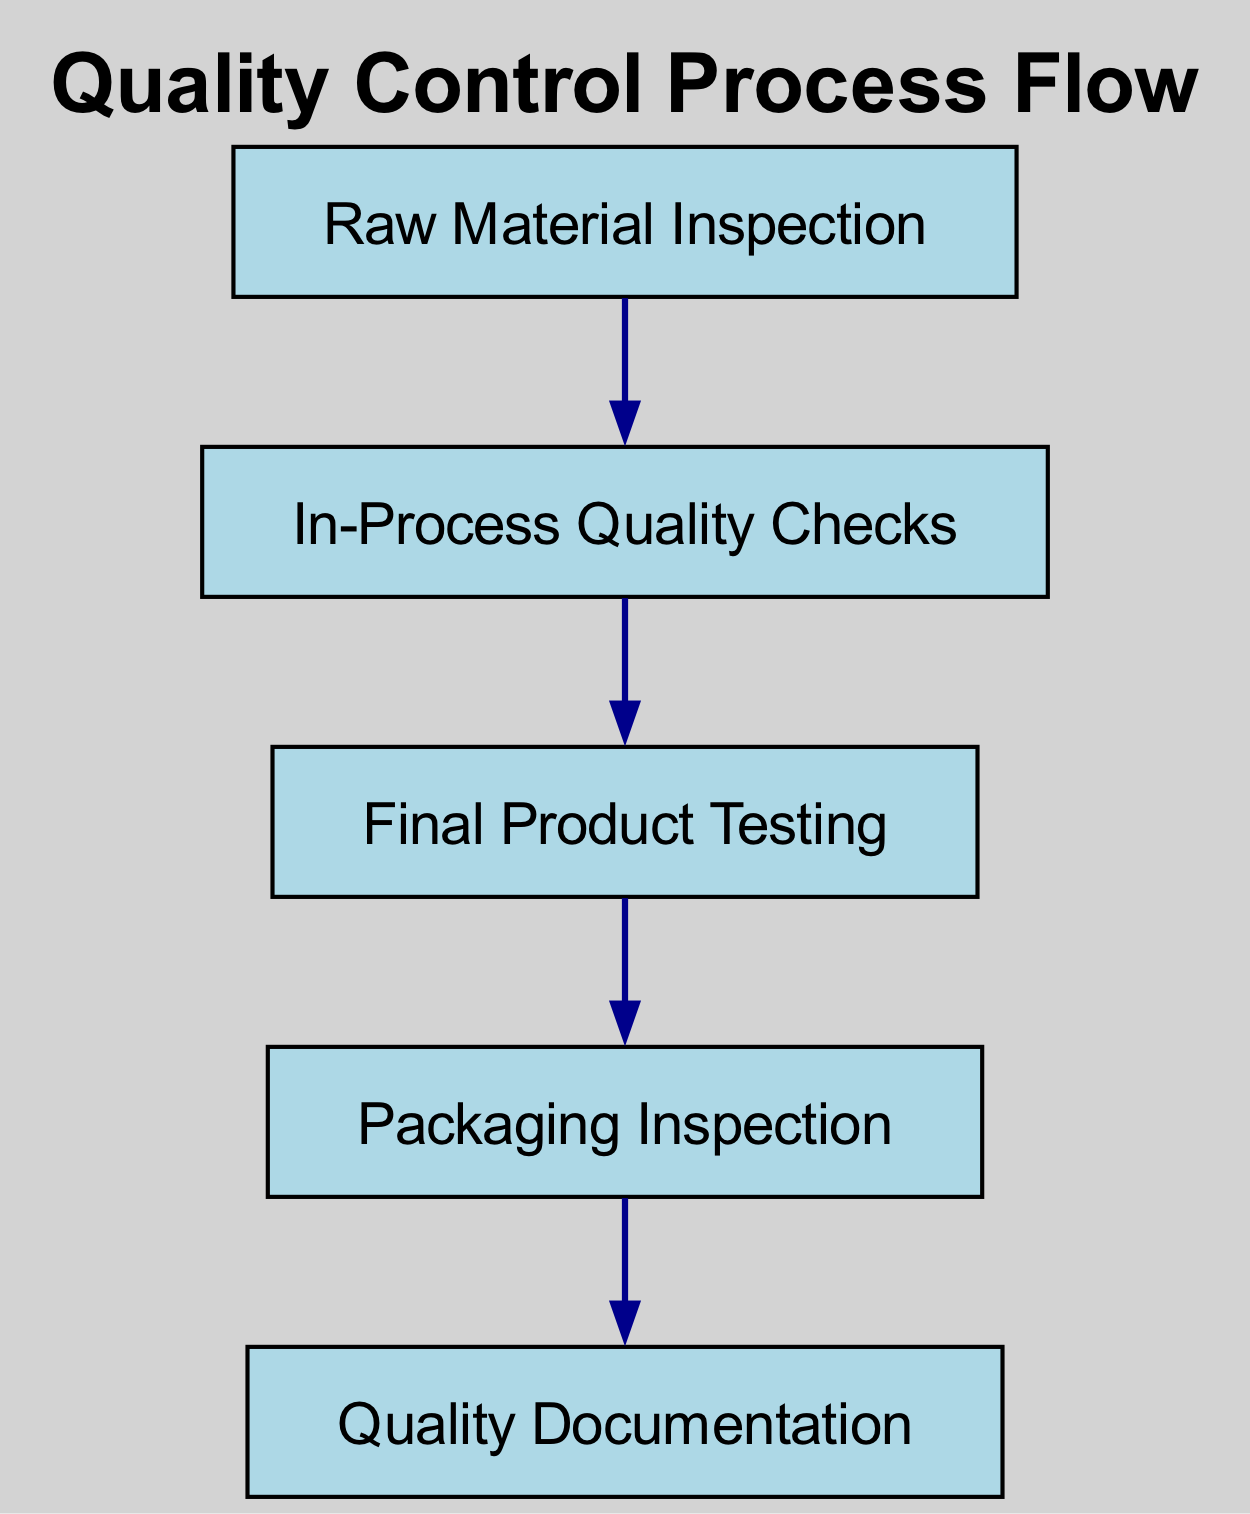What is the first step in the quality control process? The diagram starts with "Raw Material Inspection" as the first step in the quality control process.
Answer: Raw Material Inspection How many total steps are in the quality control process? Counting the individual steps in the diagram: Raw Material Inspection, In-Process Quality Checks, Final Product Testing, Packaging Inspection, and Quality Documentation totals to five distinct steps.
Answer: Five What is the last step in the production quality control process? The last step shown in the diagram is "Quality Documentation," indicating the final part of the quality control process.
Answer: Quality Documentation What follows "Final Product Testing" in the quality control process? According to the diagram, "Packaging Inspection" is the next step following "Final Product Testing."
Answer: Packaging Inspection Which step comes after "In-Process Quality Checks"? After reviewing the diagram, "Final Product Testing" is the subsequent step after "In-Process Quality Checks."
Answer: Final Product Testing What is the relationship between "Raw Material Inspection" and "In-Process Quality Checks"? The relationship is that "Raw Material Inspection" leads into "In-Process Quality Checks," indicating a sequential flow where the first step is completed before the second step begins.
Answer: Leads to What are the two steps that directly follow "Quality Documentation"? According to the diagram, "Quality Documentation" is the final step and has no subsequent steps following it, indicating an end point.
Answer: None Which step checks the quality of materials during the manufacturing process? The step focused on checking the quality of materials during manufacturing is "In-Process Quality Checks."
Answer: In-Process Quality Checks How many connections (edges) are there in the quality control flow? The diagram shows four connections, as each step (except the last) connects to the next step in the flow.
Answer: Four 